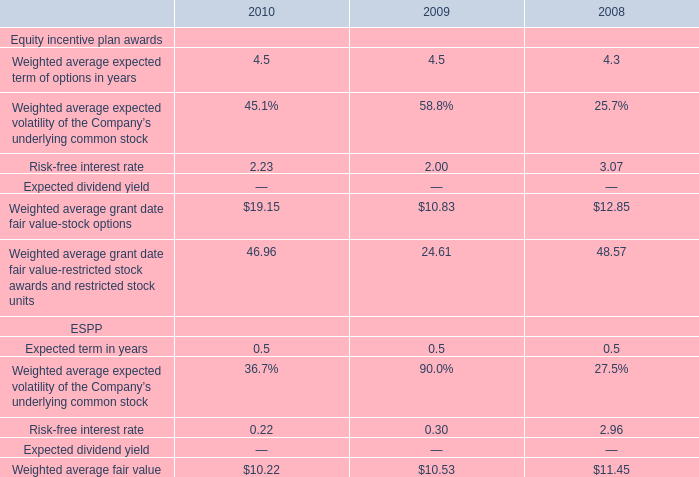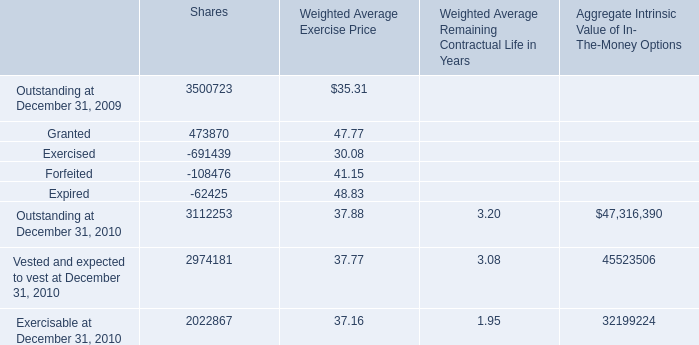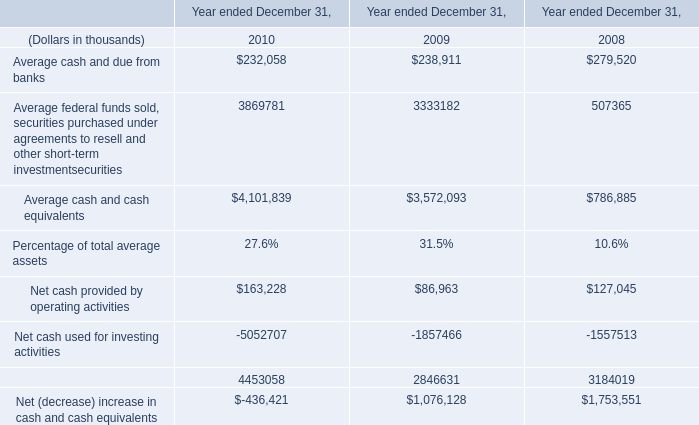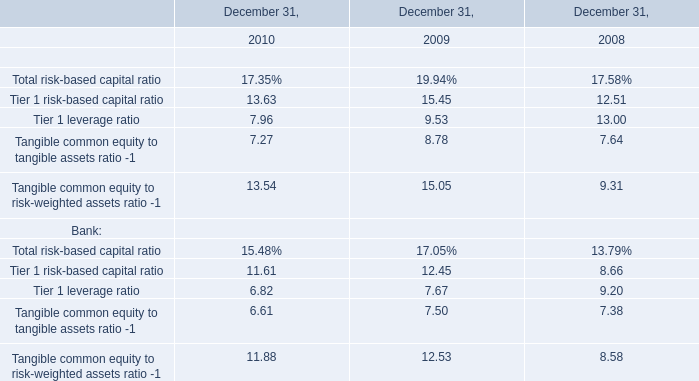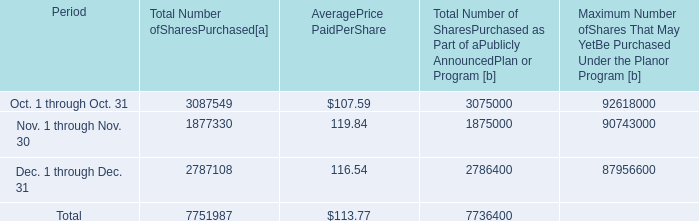What is the total amount of Nov. 1 through Nov. 30 of [EMPTY].1, Outstanding at December 31, 2010 of Shares, and Forfeited of Shares ? 
Computations: ((1877330.0 + 3112253.0) + 108476.0)
Answer: 5098059.0. 